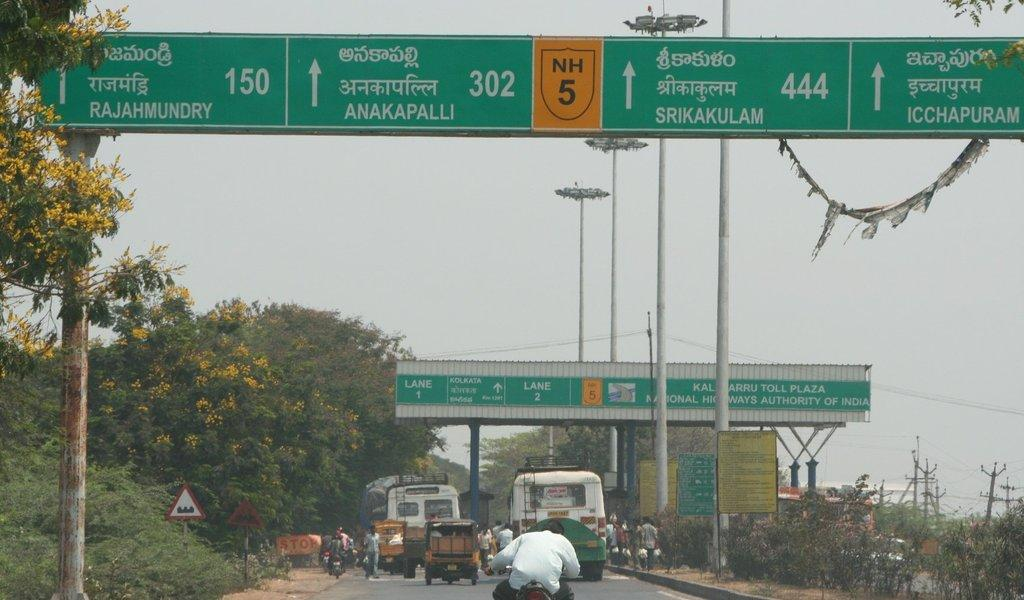Provide a one-sentence caption for the provided image. The toll plaza on a highway shows Lane 1 and Lane 2. 